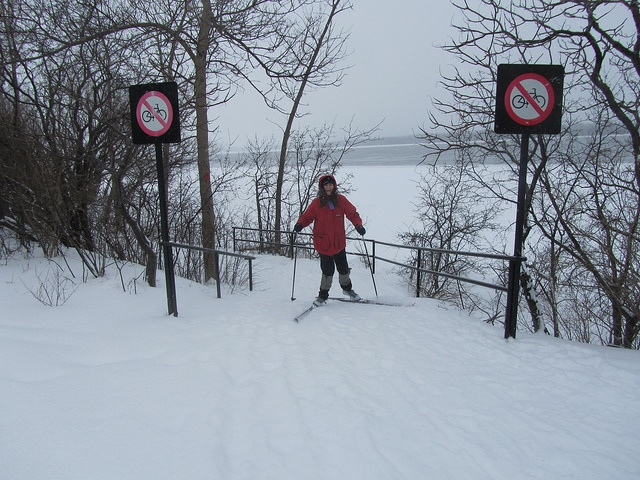Describe the objects in this image and their specific colors. I can see people in black, maroon, gray, and darkgray tones and skis in black, darkgray, and gray tones in this image. 